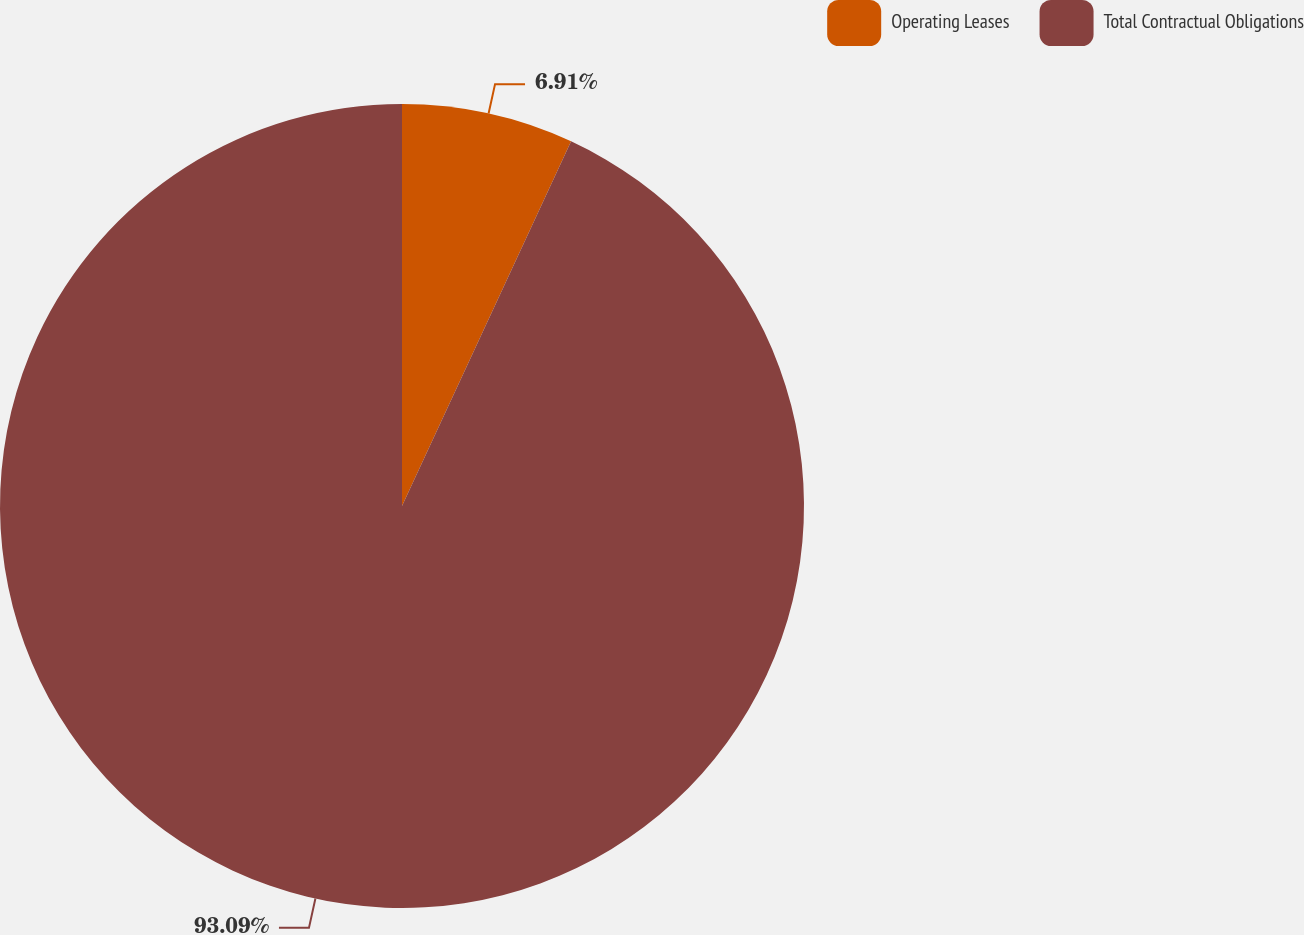Convert chart. <chart><loc_0><loc_0><loc_500><loc_500><pie_chart><fcel>Operating Leases<fcel>Total Contractual Obligations<nl><fcel>6.91%<fcel>93.09%<nl></chart> 